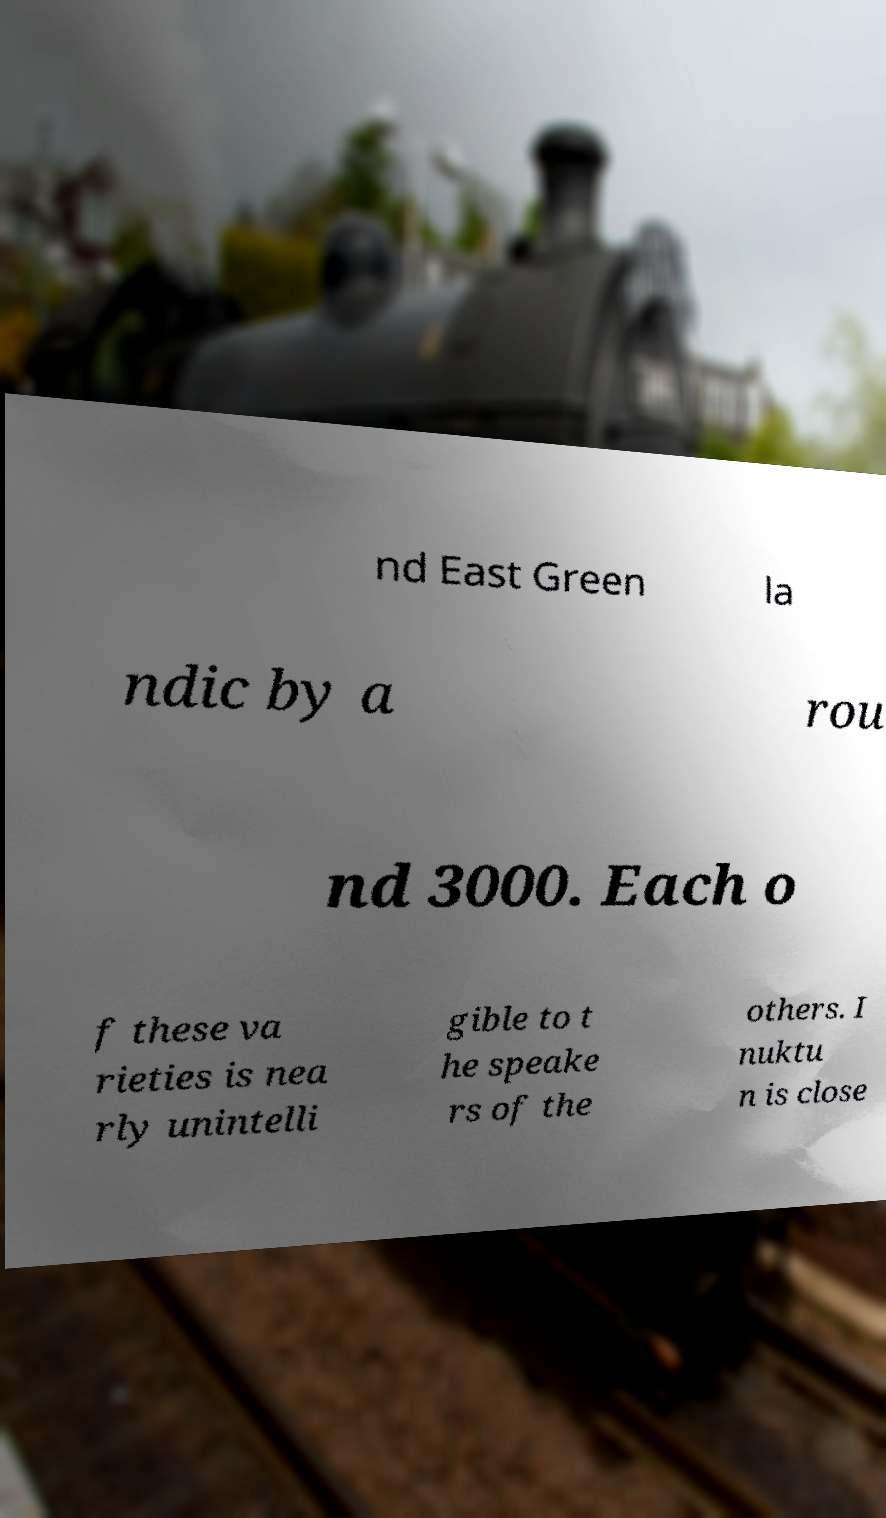Could you assist in decoding the text presented in this image and type it out clearly? nd East Green la ndic by a rou nd 3000. Each o f these va rieties is nea rly unintelli gible to t he speake rs of the others. I nuktu n is close 